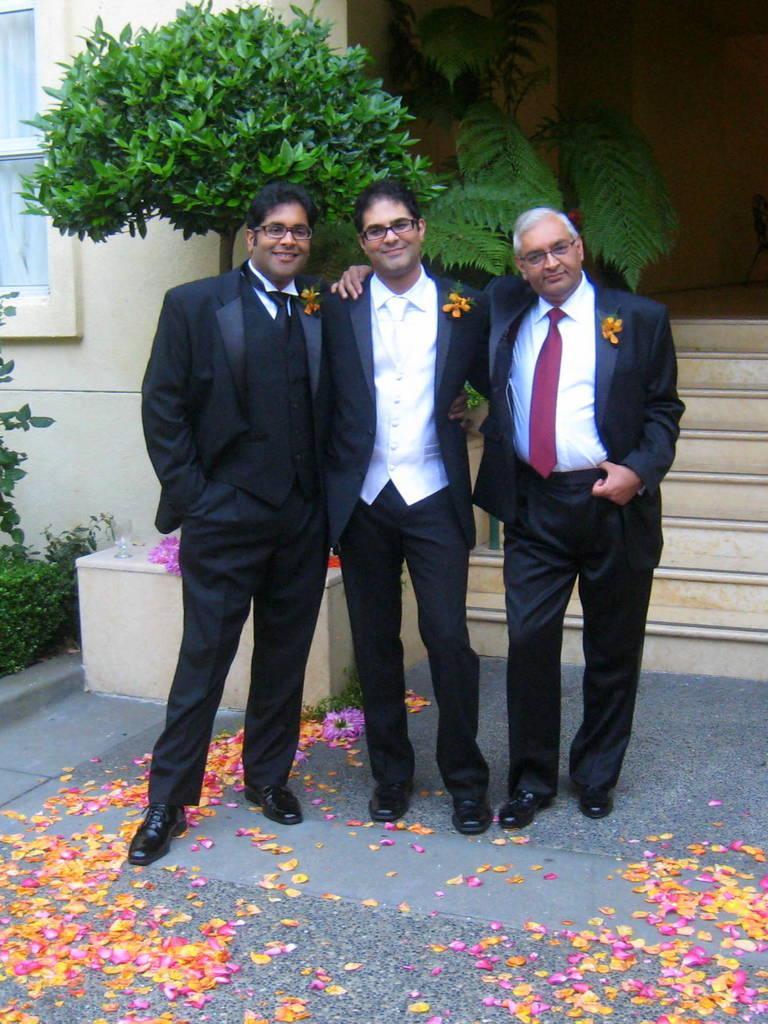Can you describe this image briefly? In the foreground of this image, there are three men standing in suit having flowers on their coats. On the bottom, there are petals of rose. In the background, there are stairs, wall, few plants and a window. 